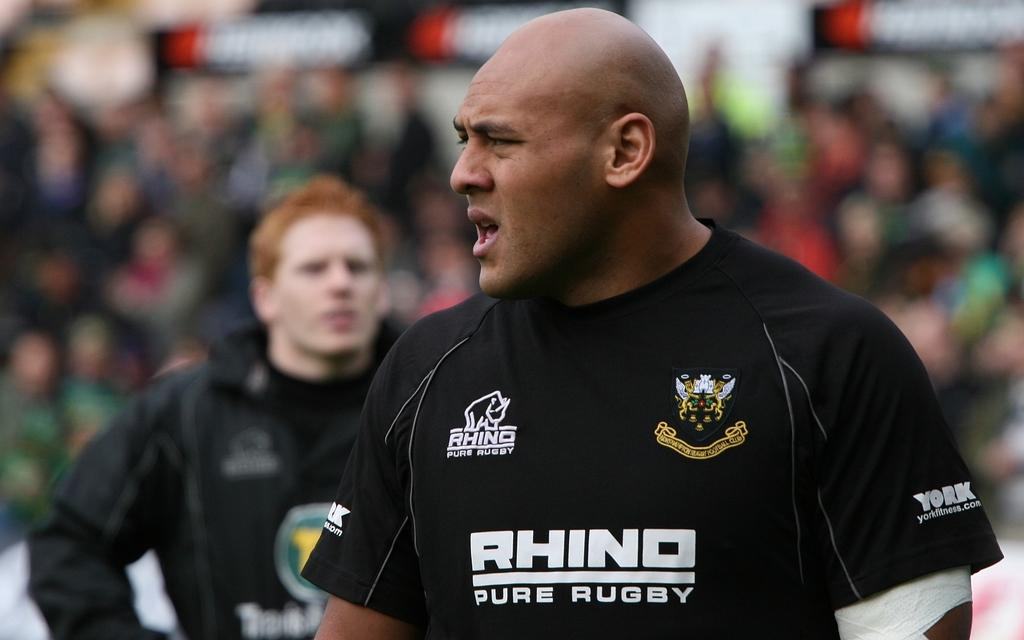Provide a one-sentence caption for the provided image. a Rhino Sure Rugby shirt on this man. 